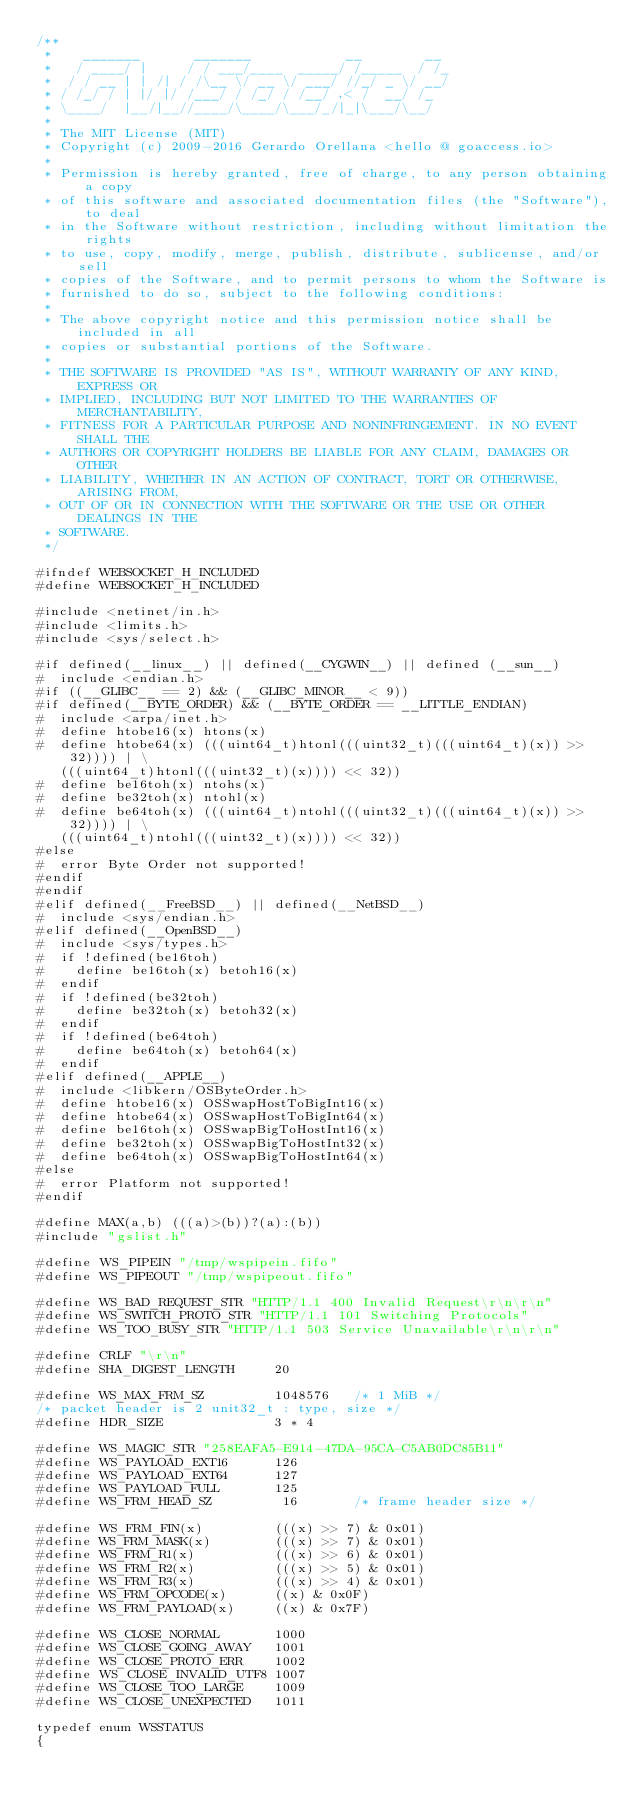Convert code to text. <code><loc_0><loc_0><loc_500><loc_500><_C_>/**
 *    _______       _______            __        __
 *   / ____/ |     / / ___/____  _____/ /_____  / /_
 *  / / __ | | /| / /\__ \/ __ \/ ___/ //_/ _ \/ __/
 * / /_/ / | |/ |/ /___/ / /_/ / /__/ ,< /  __/ /_
 * \____/  |__/|__//____/\____/\___/_/|_|\___/\__/
 *
 * The MIT License (MIT)
 * Copyright (c) 2009-2016 Gerardo Orellana <hello @ goaccess.io>
 *
 * Permission is hereby granted, free of charge, to any person obtaining a copy
 * of this software and associated documentation files (the "Software"), to deal
 * in the Software without restriction, including without limitation the rights
 * to use, copy, modify, merge, publish, distribute, sublicense, and/or sell
 * copies of the Software, and to permit persons to whom the Software is
 * furnished to do so, subject to the following conditions:
 *
 * The above copyright notice and this permission notice shall be included in all
 * copies or substantial portions of the Software.
 *
 * THE SOFTWARE IS PROVIDED "AS IS", WITHOUT WARRANTY OF ANY KIND, EXPRESS OR
 * IMPLIED, INCLUDING BUT NOT LIMITED TO THE WARRANTIES OF MERCHANTABILITY,
 * FITNESS FOR A PARTICULAR PURPOSE AND NONINFRINGEMENT. IN NO EVENT SHALL THE
 * AUTHORS OR COPYRIGHT HOLDERS BE LIABLE FOR ANY CLAIM, DAMAGES OR OTHER
 * LIABILITY, WHETHER IN AN ACTION OF CONTRACT, TORT OR OTHERWISE, ARISING FROM,
 * OUT OF OR IN CONNECTION WITH THE SOFTWARE OR THE USE OR OTHER DEALINGS IN THE
 * SOFTWARE.
 */

#ifndef WEBSOCKET_H_INCLUDED
#define WEBSOCKET_H_INCLUDED

#include <netinet/in.h>
#include <limits.h>
#include <sys/select.h>

#if defined(__linux__) || defined(__CYGWIN__) || defined (__sun__)
#  include <endian.h>
#if ((__GLIBC__ == 2) && (__GLIBC_MINOR__ < 9))
#if defined(__BYTE_ORDER) && (__BYTE_ORDER == __LITTLE_ENDIAN)
#  include <arpa/inet.h>
#  define htobe16(x) htons(x)
#  define htobe64(x) (((uint64_t)htonl(((uint32_t)(((uint64_t)(x)) >> 32)))) | \
   (((uint64_t)htonl(((uint32_t)(x)))) << 32))
#  define be16toh(x) ntohs(x)
#  define be32toh(x) ntohl(x)
#  define be64toh(x) (((uint64_t)ntohl(((uint32_t)(((uint64_t)(x)) >> 32)))) | \
   (((uint64_t)ntohl(((uint32_t)(x)))) << 32))
#else
#  error Byte Order not supported!
#endif
#endif
#elif defined(__FreeBSD__) || defined(__NetBSD__)
#  include <sys/endian.h>
#elif defined(__OpenBSD__)
#  include <sys/types.h>
#  if !defined(be16toh)
#    define be16toh(x) betoh16(x)
#  endif
#  if !defined(be32toh)
#    define be32toh(x) betoh32(x)
#  endif
#  if !defined(be64toh)
#    define be64toh(x) betoh64(x)
#  endif
#elif defined(__APPLE__)
#  include <libkern/OSByteOrder.h>
#  define htobe16(x) OSSwapHostToBigInt16(x)
#  define htobe64(x) OSSwapHostToBigInt64(x)
#  define be16toh(x) OSSwapBigToHostInt16(x)
#  define be32toh(x) OSSwapBigToHostInt32(x)
#  define be64toh(x) OSSwapBigToHostInt64(x)
#else
#  error Platform not supported!
#endif

#define MAX(a,b) (((a)>(b))?(a):(b))
#include "gslist.h"

#define WS_PIPEIN "/tmp/wspipein.fifo"
#define WS_PIPEOUT "/tmp/wspipeout.fifo"

#define WS_BAD_REQUEST_STR "HTTP/1.1 400 Invalid Request\r\n\r\n"
#define WS_SWITCH_PROTO_STR "HTTP/1.1 101 Switching Protocols"
#define WS_TOO_BUSY_STR "HTTP/1.1 503 Service Unavailable\r\n\r\n"

#define CRLF "\r\n"
#define SHA_DIGEST_LENGTH     20

#define WS_MAX_FRM_SZ         1048576   /* 1 MiB */
/* packet header is 2 unit32_t : type, size */
#define HDR_SIZE              3 * 4

#define WS_MAGIC_STR "258EAFA5-E914-47DA-95CA-C5AB0DC85B11"
#define WS_PAYLOAD_EXT16      126
#define WS_PAYLOAD_EXT64      127
#define WS_PAYLOAD_FULL       125
#define WS_FRM_HEAD_SZ         16       /* frame header size */

#define WS_FRM_FIN(x)         (((x) >> 7) & 0x01)
#define WS_FRM_MASK(x)        (((x) >> 7) & 0x01)
#define WS_FRM_R1(x)          (((x) >> 6) & 0x01)
#define WS_FRM_R2(x)          (((x) >> 5) & 0x01)
#define WS_FRM_R3(x)          (((x) >> 4) & 0x01)
#define WS_FRM_OPCODE(x)      ((x) & 0x0F)
#define WS_FRM_PAYLOAD(x)     ((x) & 0x7F)

#define WS_CLOSE_NORMAL       1000
#define WS_CLOSE_GOING_AWAY   1001
#define WS_CLOSE_PROTO_ERR    1002
#define WS_CLOSE_INVALID_UTF8 1007
#define WS_CLOSE_TOO_LARGE    1009
#define WS_CLOSE_UNEXPECTED   1011

typedef enum WSSTATUS
{</code> 